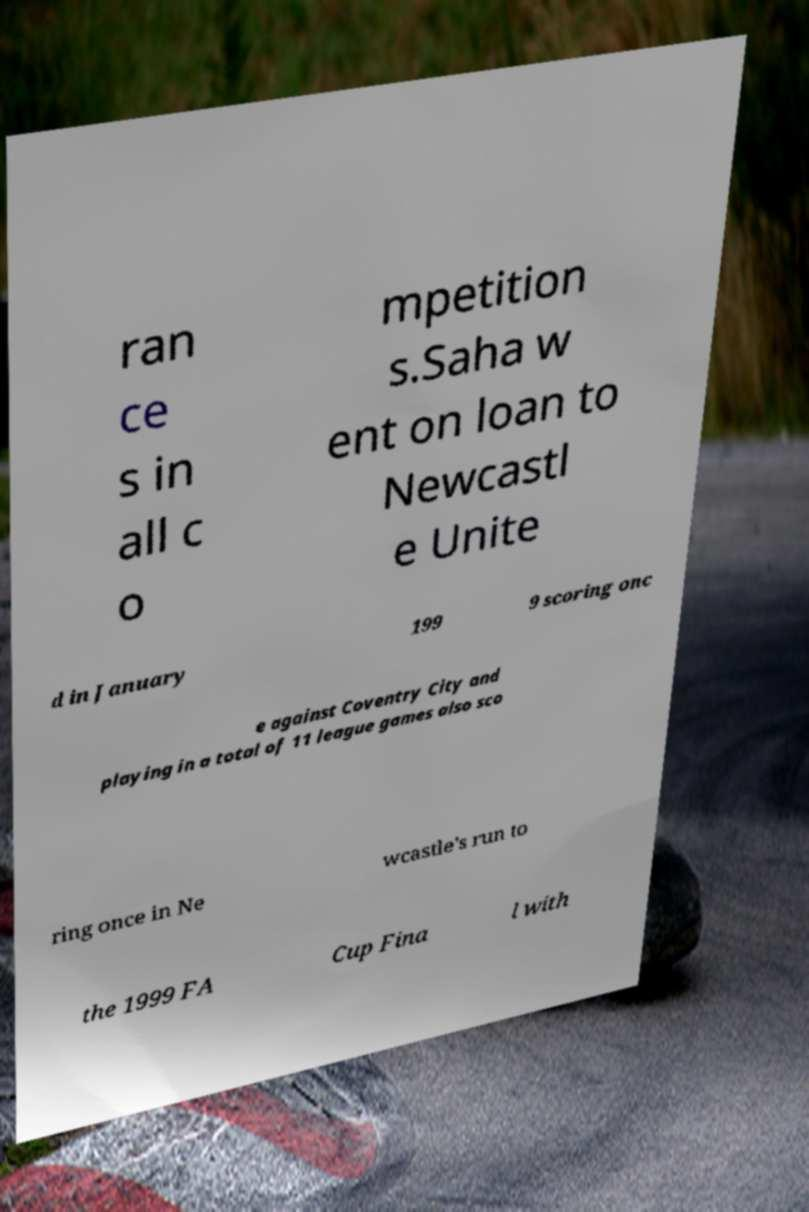Can you accurately transcribe the text from the provided image for me? ran ce s in all c o mpetition s.Saha w ent on loan to Newcastl e Unite d in January 199 9 scoring onc e against Coventry City and playing in a total of 11 league games also sco ring once in Ne wcastle's run to the 1999 FA Cup Fina l with 